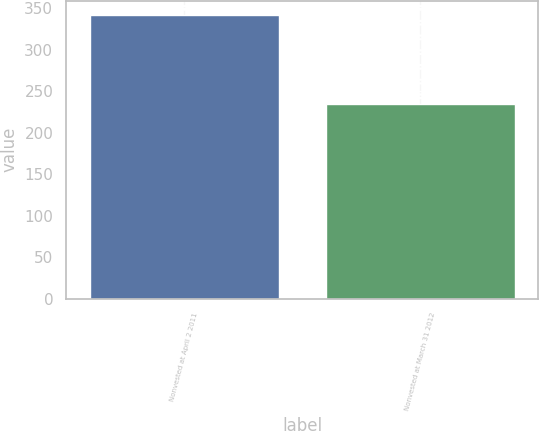Convert chart to OTSL. <chart><loc_0><loc_0><loc_500><loc_500><bar_chart><fcel>Nonvested at April 2 2011<fcel>Nonvested at March 31 2012<nl><fcel>342<fcel>235<nl></chart> 